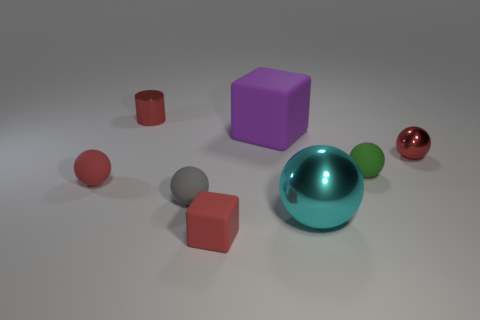Subtract all tiny red shiny spheres. How many spheres are left? 4 Add 1 small red metallic things. How many objects exist? 9 Subtract all red spheres. How many spheres are left? 3 Subtract all cylinders. How many objects are left? 7 Subtract all blue spheres. How many brown cylinders are left? 0 Subtract all large yellow cubes. Subtract all small red matte blocks. How many objects are left? 7 Add 4 small gray rubber spheres. How many small gray rubber spheres are left? 5 Add 2 small objects. How many small objects exist? 8 Subtract 0 blue blocks. How many objects are left? 8 Subtract 2 cubes. How many cubes are left? 0 